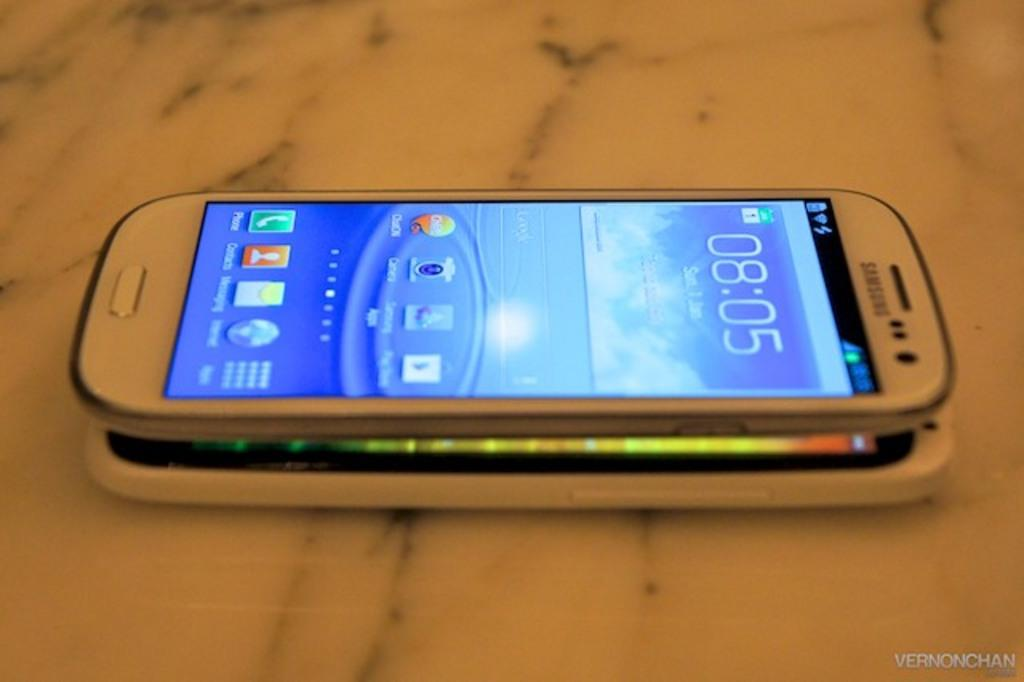<image>
Offer a succinct explanation of the picture presented. Silver Samsung phone with the time at 8:05 on top of a table. 